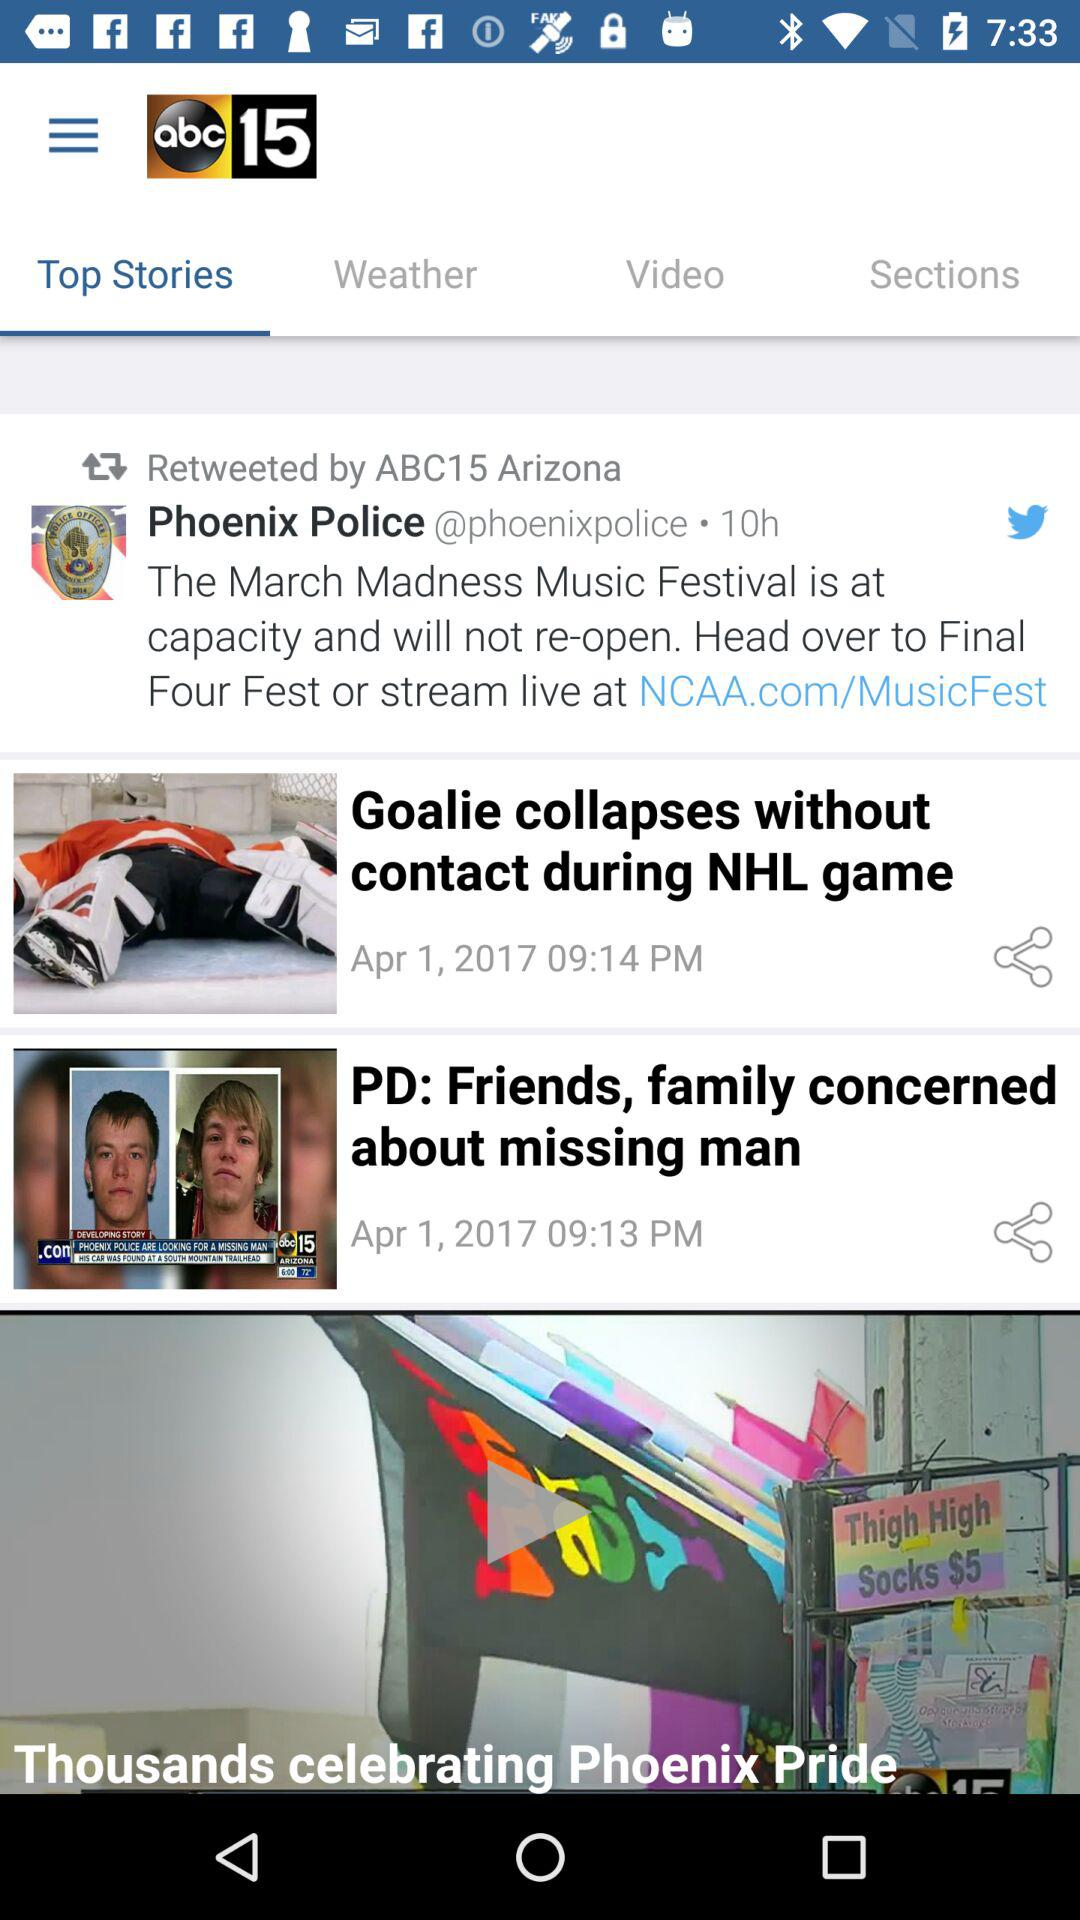Which tab is selected? The selected tab is "Top Stories". 